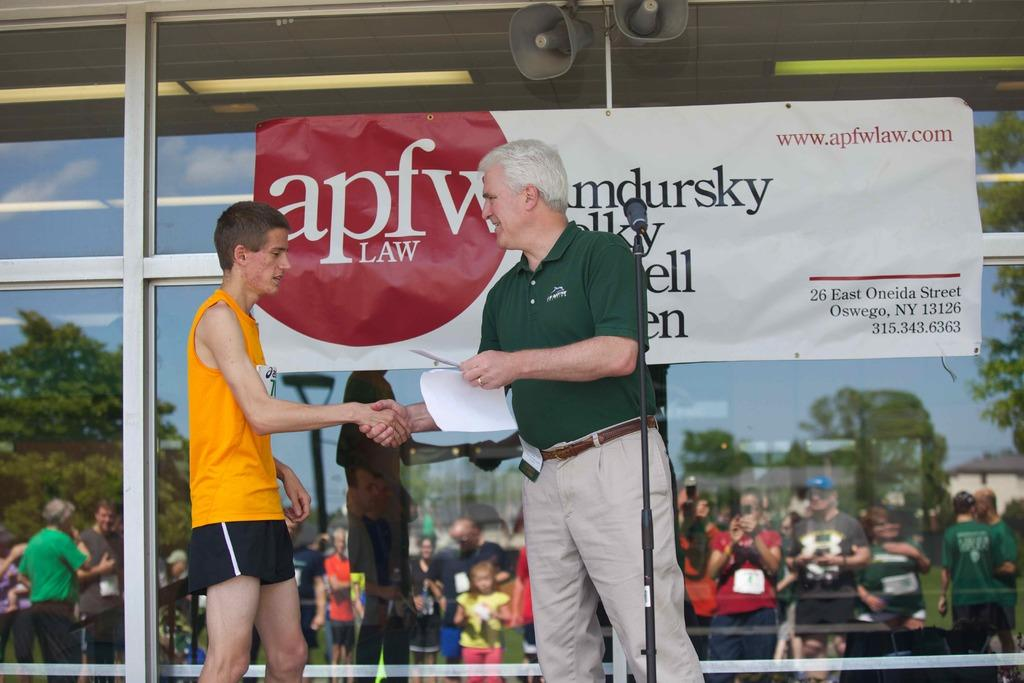<image>
Provide a brief description of the given image. the letters apfv on a sign behind people 